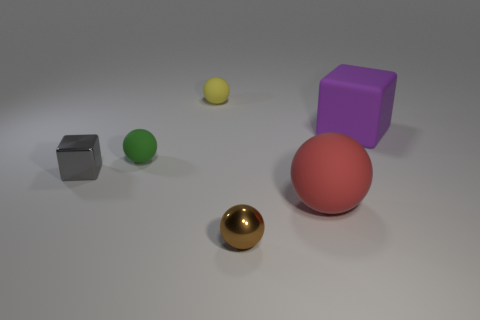Subtract all tiny green balls. How many balls are left? 3 Add 2 metal spheres. How many objects exist? 8 Subtract all yellow balls. How many balls are left? 3 Subtract all spheres. How many objects are left? 2 Subtract all blue blocks. Subtract all purple cylinders. How many blocks are left? 2 Subtract all tiny objects. Subtract all big green cubes. How many objects are left? 2 Add 4 gray things. How many gray things are left? 5 Add 5 large green metallic spheres. How many large green metallic spheres exist? 5 Subtract 1 gray cubes. How many objects are left? 5 Subtract 2 balls. How many balls are left? 2 